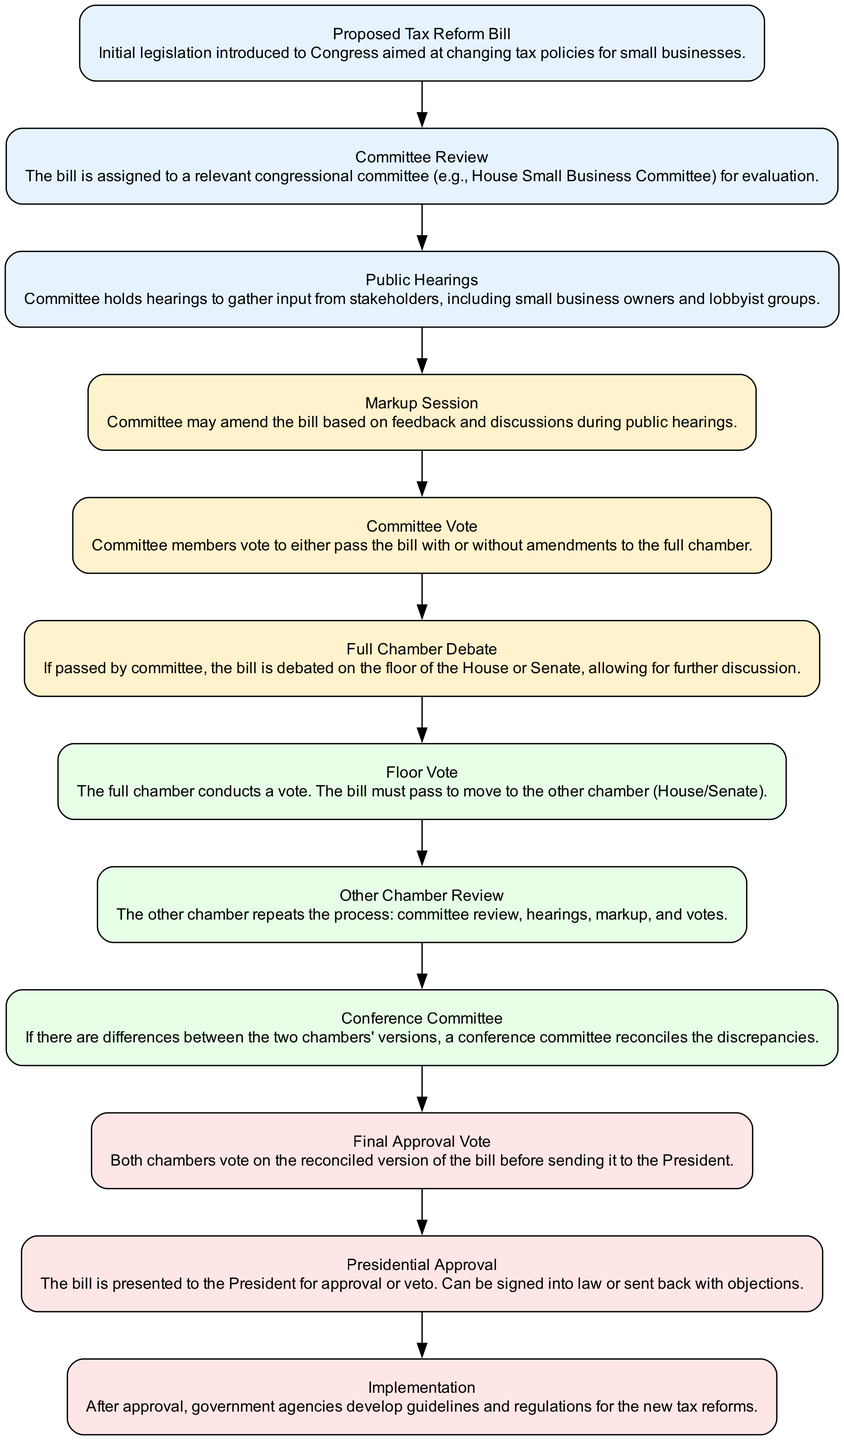What is the first step in the legislative process for small business tax reforms? The first step is represented by the node labeled "Proposed Tax Reform Bill," indicating the introduction of the legislation to Congress.
Answer: Proposed Tax Reform Bill How many stages are there in the legislative process according to the diagram? By counting the nodes that represent different stages, there are a total of 12 distinct stages in the process.
Answer: 12 What type of input is gathered during the Public Hearings stage? The Public Hearings stage specifically gathers input from stakeholders, such as small business owners and lobbyist groups.
Answer: Stakeholder input Which stage follows the Committee Review? The stage that follows the Committee Review is Public Hearings, where the committee seeks input and feedback on the proposed bill.
Answer: Public Hearings Are amendments made during the Full Chamber Debate? No, amendments are typically made during the Markup Session prior to the Full Chamber Debate, which focuses on discussion rather than further changes.
Answer: No What happens if there are discrepancies between the two chambers' versions of the bill? If discrepancies arise, a Conference Committee is formed to reconcile the differences between the versions from each chamber.
Answer: Conference Committee What is the outcome if the Final Approval Vote is successful? A successful Final Approval Vote means both chambers agree on the reconciled version of the bill, allowing it to proceed to the President for approval.
Answer: Presidential Approval Which nodes are colored light yellow in the diagram? The nodes that represent the stages from Committee Review to Floor Vote are colored light yellow, indicating the middle stages of the process.
Answer: Committee Review, Public Hearings, Markup Session, Committee Vote, Full Chamber Debate What is the last stage of the legislative process for tax reforms? The last stage is Implementation, where government agencies develop guidelines and regulations for the new tax reforms after presidential approval.
Answer: Implementation 